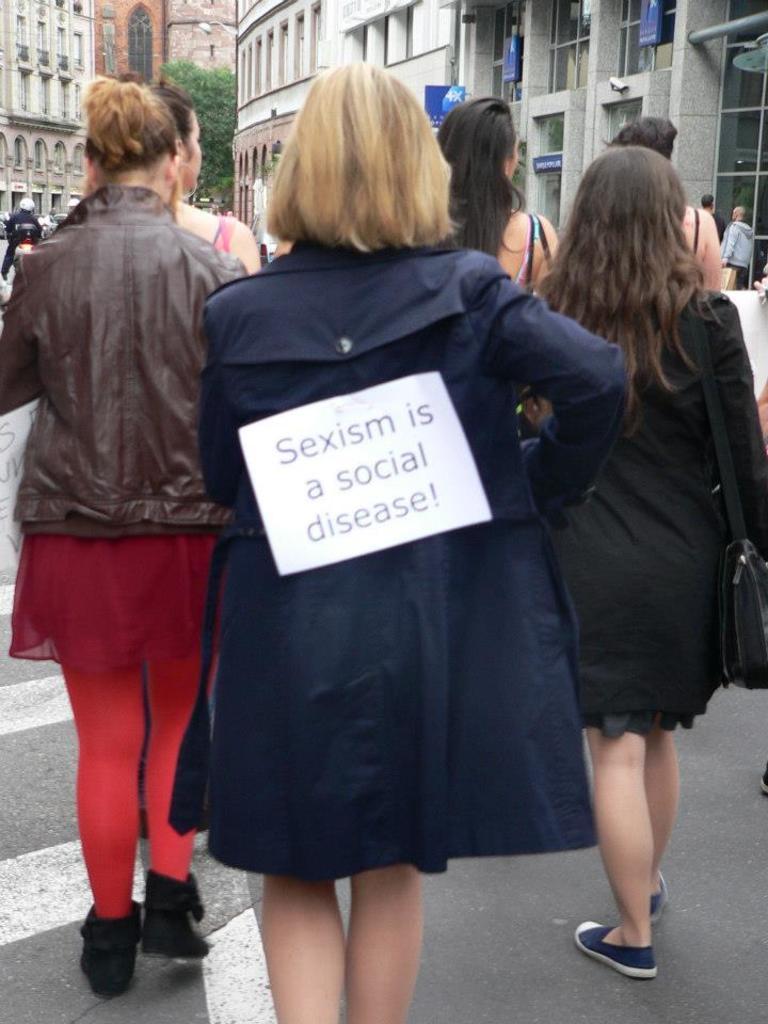Describe this image in one or two sentences. In this image we can see many people and few people carrying some objects. We can see some text on the board. There are few buildings in the image. There is a tree in the image. 